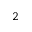<formula> <loc_0><loc_0><loc_500><loc_500>_ { 2 }</formula> 